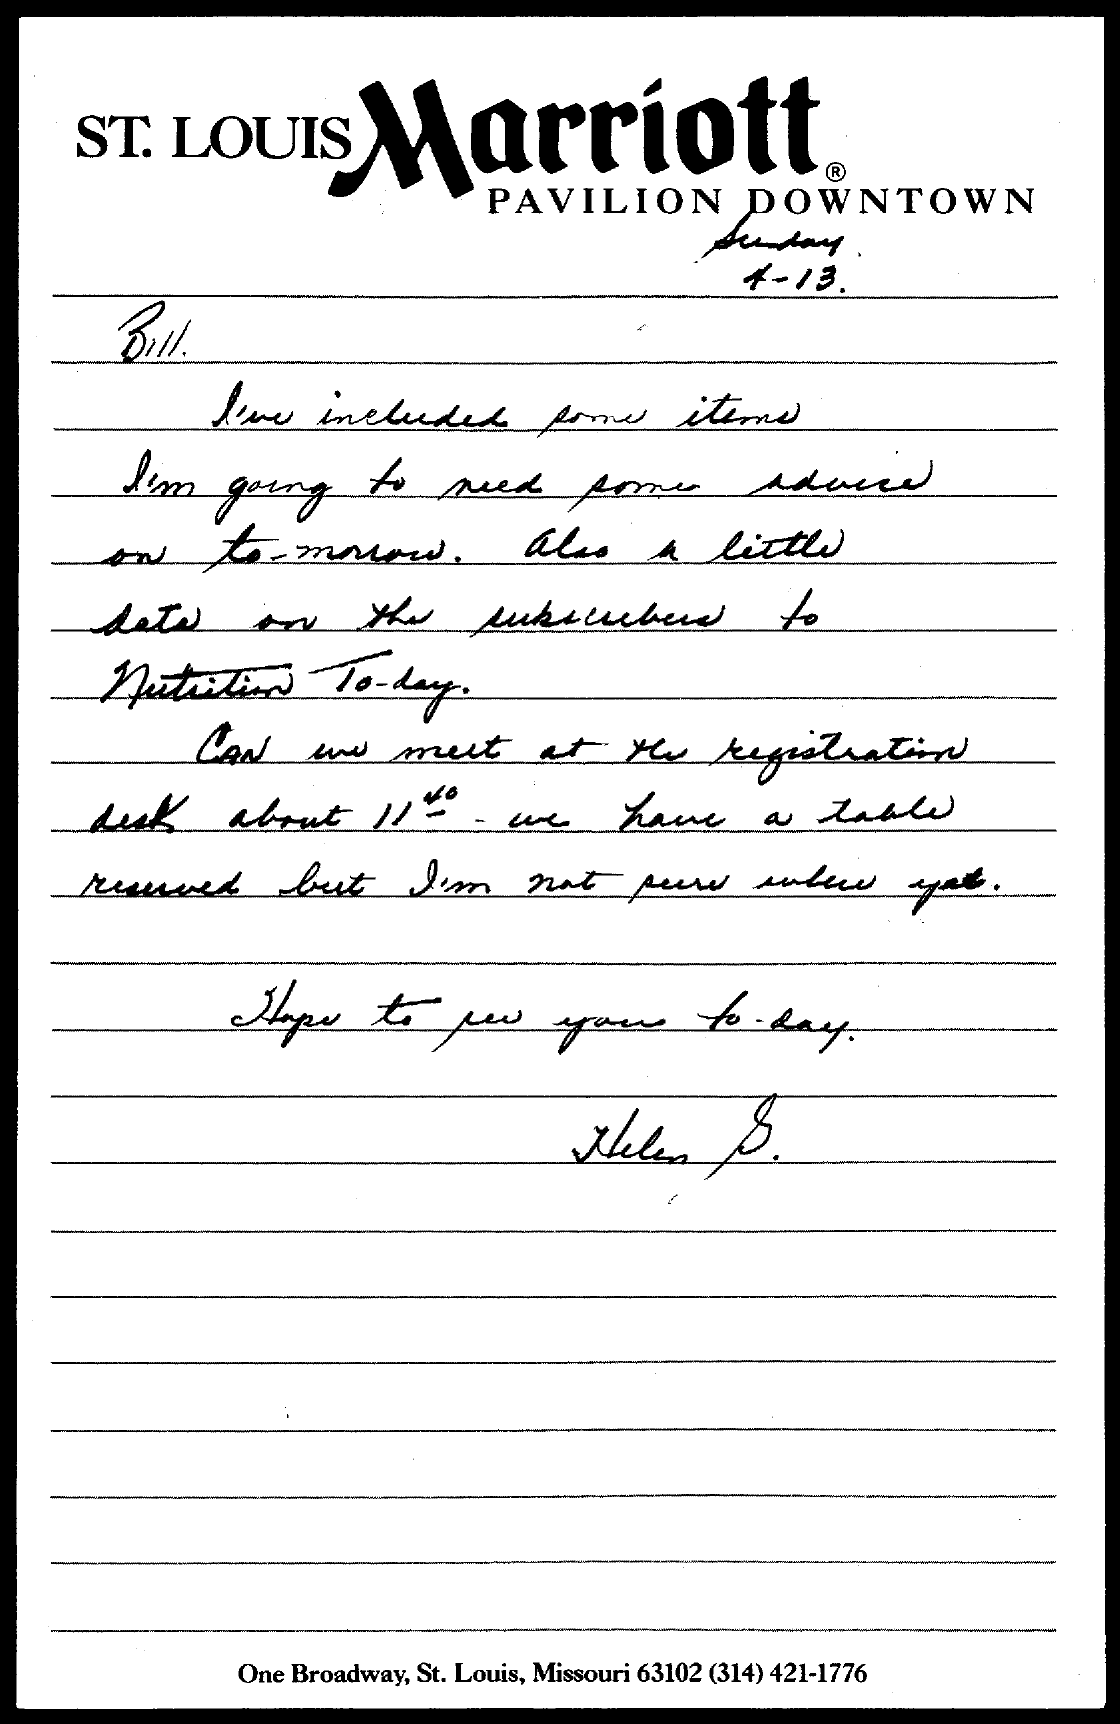Outline some significant characteristics in this image. The date mentioned in the given page is April 13th. 